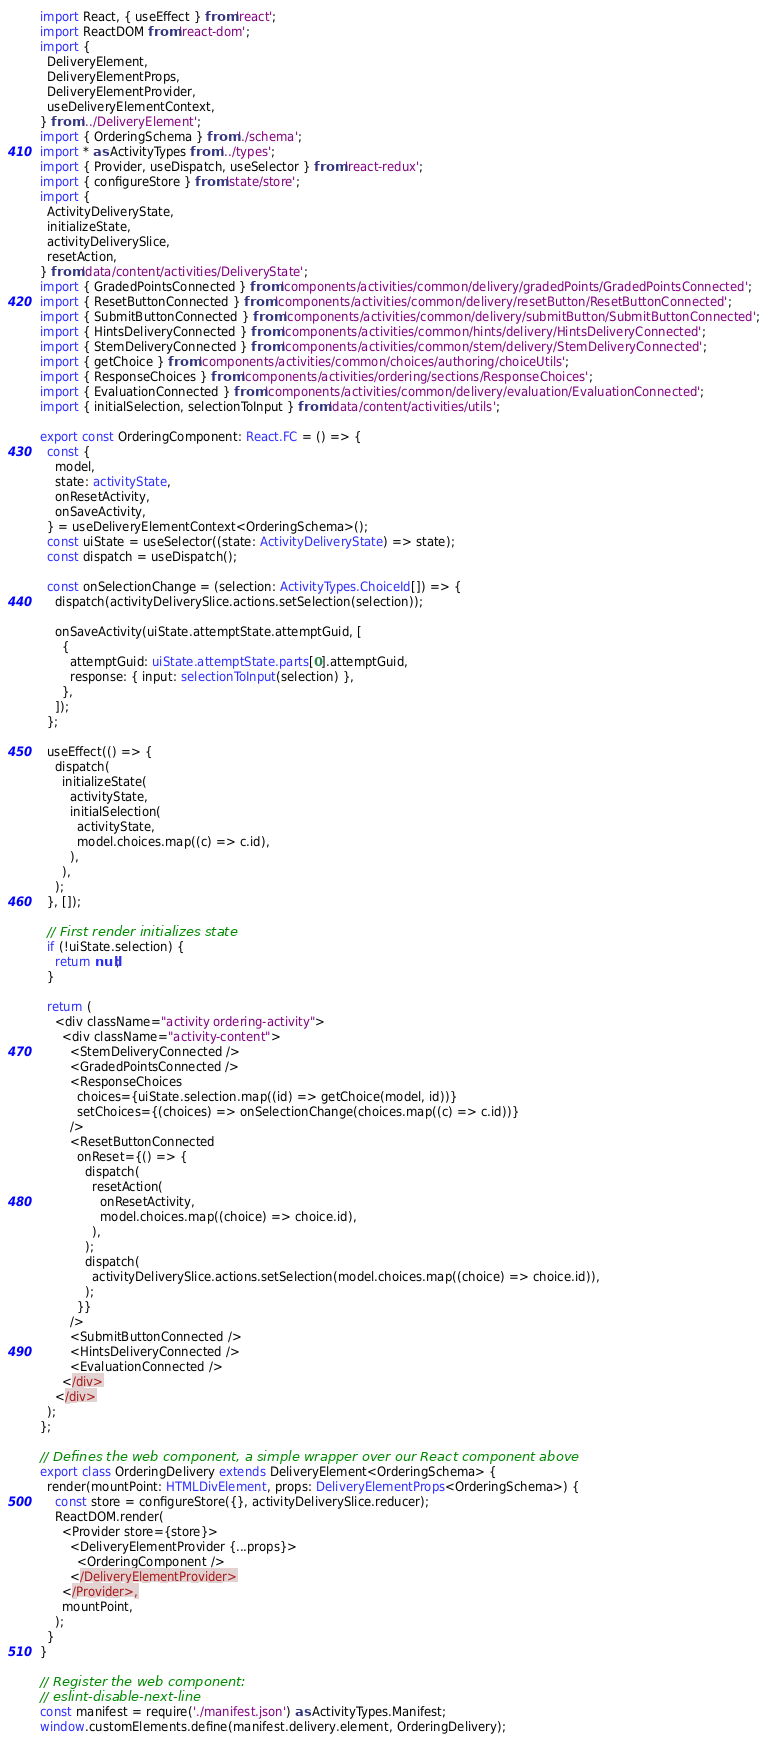Convert code to text. <code><loc_0><loc_0><loc_500><loc_500><_TypeScript_>import React, { useEffect } from 'react';
import ReactDOM from 'react-dom';
import {
  DeliveryElement,
  DeliveryElementProps,
  DeliveryElementProvider,
  useDeliveryElementContext,
} from '../DeliveryElement';
import { OrderingSchema } from './schema';
import * as ActivityTypes from '../types';
import { Provider, useDispatch, useSelector } from 'react-redux';
import { configureStore } from 'state/store';
import {
  ActivityDeliveryState,
  initializeState,
  activityDeliverySlice,
  resetAction,
} from 'data/content/activities/DeliveryState';
import { GradedPointsConnected } from 'components/activities/common/delivery/gradedPoints/GradedPointsConnected';
import { ResetButtonConnected } from 'components/activities/common/delivery/resetButton/ResetButtonConnected';
import { SubmitButtonConnected } from 'components/activities/common/delivery/submitButton/SubmitButtonConnected';
import { HintsDeliveryConnected } from 'components/activities/common/hints/delivery/HintsDeliveryConnected';
import { StemDeliveryConnected } from 'components/activities/common/stem/delivery/StemDeliveryConnected';
import { getChoice } from 'components/activities/common/choices/authoring/choiceUtils';
import { ResponseChoices } from 'components/activities/ordering/sections/ResponseChoices';
import { EvaluationConnected } from 'components/activities/common/delivery/evaluation/EvaluationConnected';
import { initialSelection, selectionToInput } from 'data/content/activities/utils';

export const OrderingComponent: React.FC = () => {
  const {
    model,
    state: activityState,
    onResetActivity,
    onSaveActivity,
  } = useDeliveryElementContext<OrderingSchema>();
  const uiState = useSelector((state: ActivityDeliveryState) => state);
  const dispatch = useDispatch();

  const onSelectionChange = (selection: ActivityTypes.ChoiceId[]) => {
    dispatch(activityDeliverySlice.actions.setSelection(selection));

    onSaveActivity(uiState.attemptState.attemptGuid, [
      {
        attemptGuid: uiState.attemptState.parts[0].attemptGuid,
        response: { input: selectionToInput(selection) },
      },
    ]);
  };

  useEffect(() => {
    dispatch(
      initializeState(
        activityState,
        initialSelection(
          activityState,
          model.choices.map((c) => c.id),
        ),
      ),
    );
  }, []);

  // First render initializes state
  if (!uiState.selection) {
    return null;
  }

  return (
    <div className="activity ordering-activity">
      <div className="activity-content">
        <StemDeliveryConnected />
        <GradedPointsConnected />
        <ResponseChoices
          choices={uiState.selection.map((id) => getChoice(model, id))}
          setChoices={(choices) => onSelectionChange(choices.map((c) => c.id))}
        />
        <ResetButtonConnected
          onReset={() => {
            dispatch(
              resetAction(
                onResetActivity,
                model.choices.map((choice) => choice.id),
              ),
            );
            dispatch(
              activityDeliverySlice.actions.setSelection(model.choices.map((choice) => choice.id)),
            );
          }}
        />
        <SubmitButtonConnected />
        <HintsDeliveryConnected />
        <EvaluationConnected />
      </div>
    </div>
  );
};

// Defines the web component, a simple wrapper over our React component above
export class OrderingDelivery extends DeliveryElement<OrderingSchema> {
  render(mountPoint: HTMLDivElement, props: DeliveryElementProps<OrderingSchema>) {
    const store = configureStore({}, activityDeliverySlice.reducer);
    ReactDOM.render(
      <Provider store={store}>
        <DeliveryElementProvider {...props}>
          <OrderingComponent />
        </DeliveryElementProvider>
      </Provider>,
      mountPoint,
    );
  }
}

// Register the web component:
// eslint-disable-next-line
const manifest = require('./manifest.json') as ActivityTypes.Manifest;
window.customElements.define(manifest.delivery.element, OrderingDelivery);
</code> 